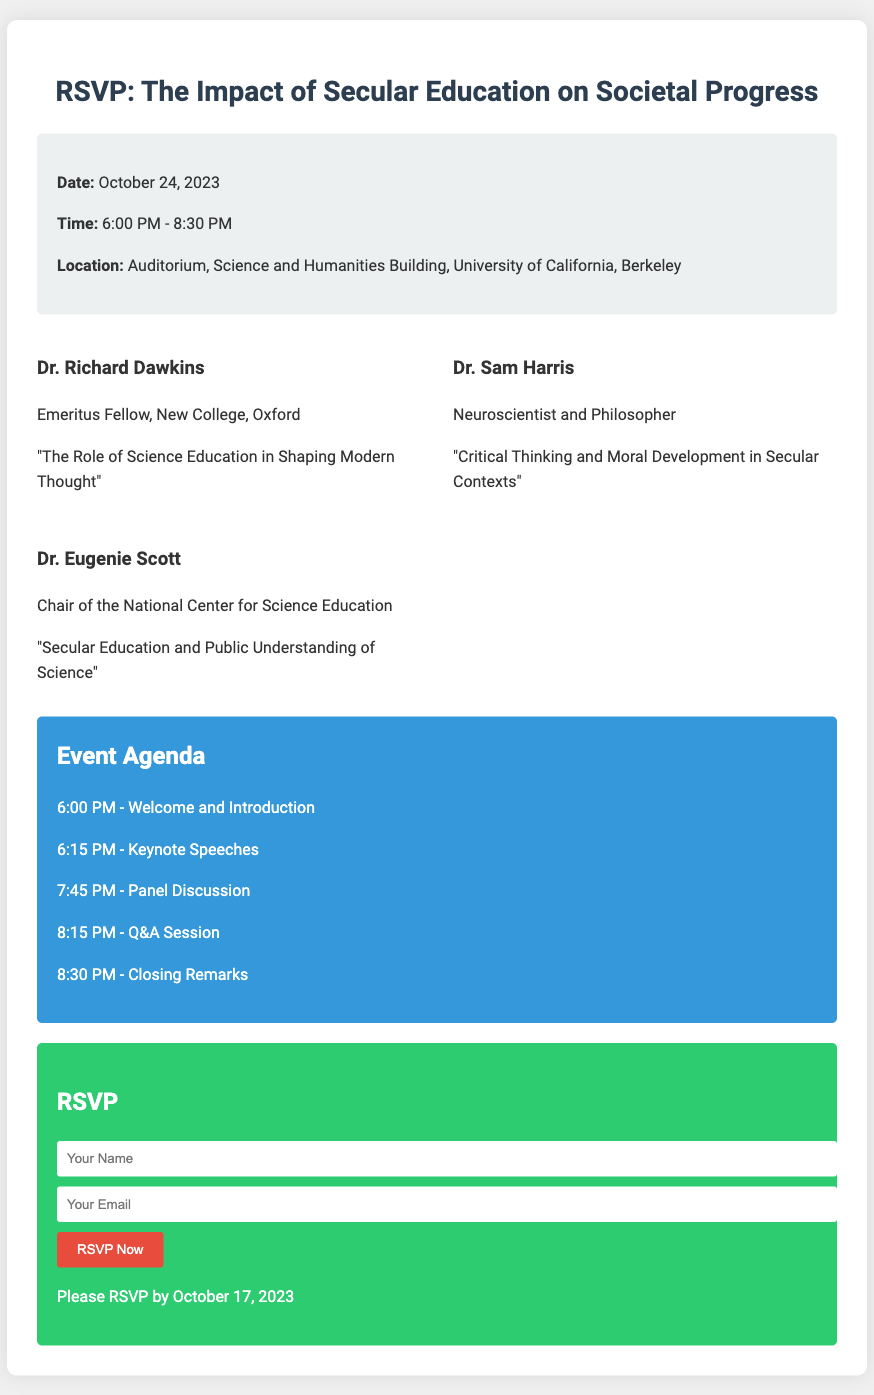what is the date of the event? The date of the event is provided in the document under the information section.
Answer: October 24, 2023 what is the duration of the event? The document specifies the time range, which indicates the start and end of the event.
Answer: 6:00 PM - 8:30 PM who is the first speaker listed? The speaker's name is mentioned at the top of the speakers' section.
Answer: Dr. Richard Dawkins what is the title of Dr. Sam Harris's speech? The title is listed directly under the speaker's name in the speakers' section.
Answer: Critical Thinking and Moral Development in Secular Contexts how many speakers are listed for the event? The number of speakers can be counted from the speakers' section in the document.
Answer: Three which university is hosting the event? The hosting university is mentioned in the location section of the document.
Answer: University of California, Berkeley at what time does the Q&A session start? The time for the Q&A session is provided in the agenda section of the document.
Answer: 8:15 PM what is the RSVP deadline? The RSVP deadline is stated at the bottom of the RSVP section.
Answer: October 17, 2023 what type of form is provided to RSVP? The type of form can be identified from the context, indicating it is a request for confirmation of attendance.
Answer: RSVP form 